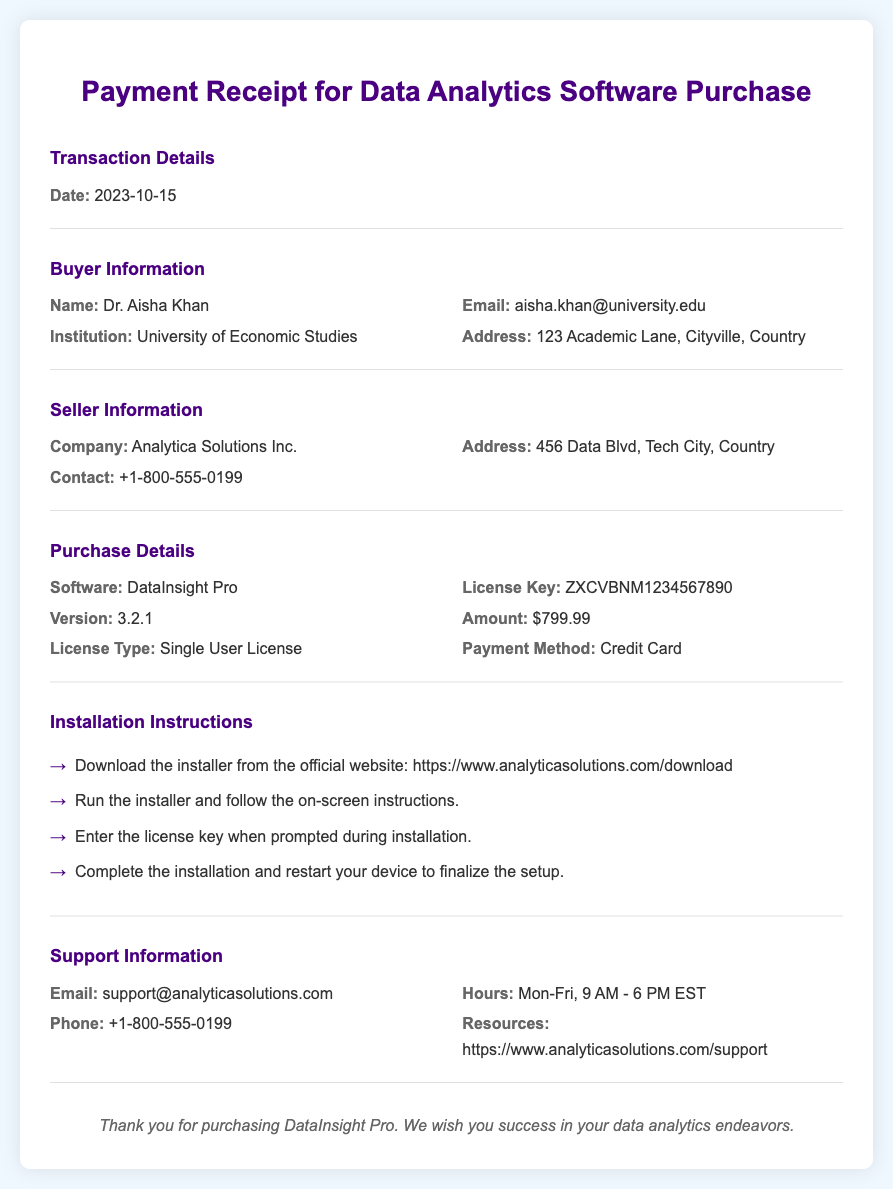What is the date of the transaction? The date is specified in the Transaction Details section of the document.
Answer: 2023-10-15 Who is the buyer? The buyer's information is provided under the Buyer Information section.
Answer: Dr. Aisha Khan What is the license type for the software? License type is mentioned in the Purchase Details section of the document.
Answer: Single User License What is the amount paid for the software? The amount is listed in the Purchase Details section.
Answer: $799.99 What is the license key for the software? The license key is provided in the Purchase Details section.
Answer: ZXCVBNM1234567890 How can the buyer contact support? Support contact information is available in the Support Information section.
Answer: support@analyticasolutions.com What version of the software is purchased? The version is specified in the Purchase Details section.
Answer: 3.2.1 What are the installation instructions? Installation steps are outlined in the Installation Instructions section of the document.
Answer: 1. Download the installer from the official website: https://www.analyticasolutions.com/download. 2. Run the installer and follow the on-screen instructions. 3. Enter the license key when prompted during installation. 4. Complete the installation and restart your device to finalize the setup What are the support hours? Support hours are indicated in the Support Information section of the document.
Answer: Mon-Fri, 9 AM - 6 PM EST 